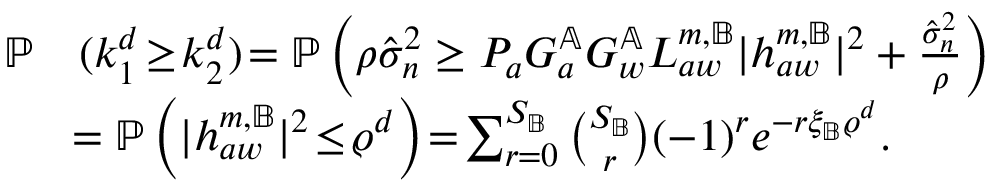<formula> <loc_0><loc_0><loc_500><loc_500>\begin{array} { r l } { \mathbb { P } } & { ( k _ { 1 } ^ { d } \, \geq \, k _ { 2 } ^ { d } ) \, = \mathbb { P } \left ( \rho \hat { \sigma } _ { n } ^ { 2 } \geq P _ { a } G _ { a } ^ { \mathbb { A } } G _ { w } ^ { \mathbb { A } } L _ { a w } ^ { m , \mathbb { B } } | { h } _ { a w } ^ { m , \mathbb { B } } | ^ { 2 } + \frac { \hat { \sigma } _ { n } ^ { 2 } } { \rho } \right ) } \\ & { \, = \mathbb { P } \left ( | { h } _ { a w } ^ { m , \mathbb { B } } | ^ { 2 } \, \leq \, \varrho ^ { d } \right ) \, = \, \sum _ { r = 0 } ^ { S _ { \mathbb { B } } } \binom { S _ { \mathbb { B } } } { r } ( - 1 ) ^ { r } e ^ { - r \xi _ { \mathbb { B } } \varrho ^ { d } } . } \end{array}</formula> 